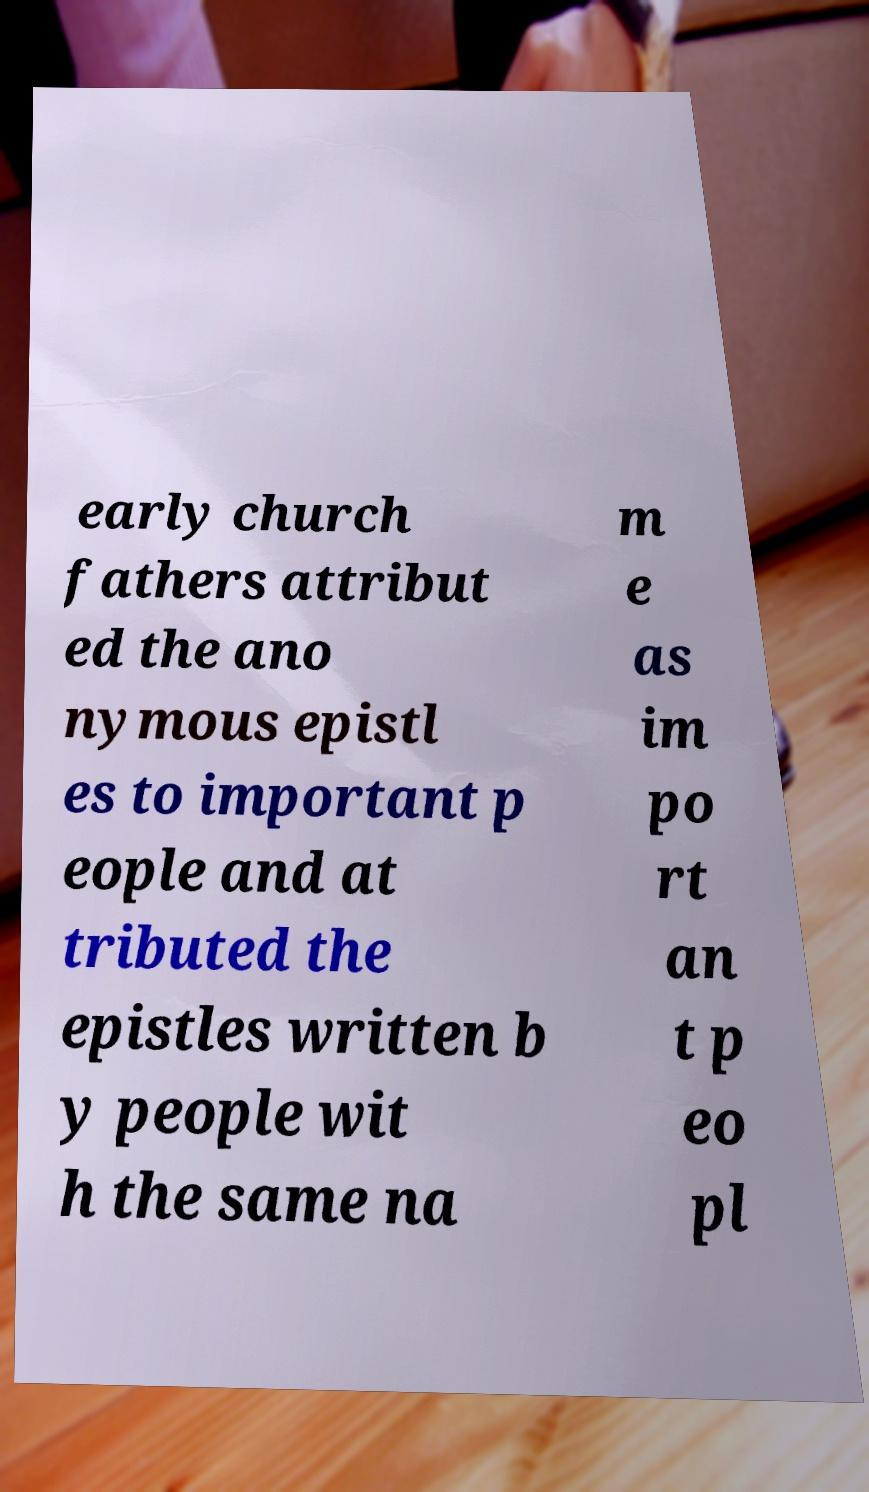Can you accurately transcribe the text from the provided image for me? early church fathers attribut ed the ano nymous epistl es to important p eople and at tributed the epistles written b y people wit h the same na m e as im po rt an t p eo pl 